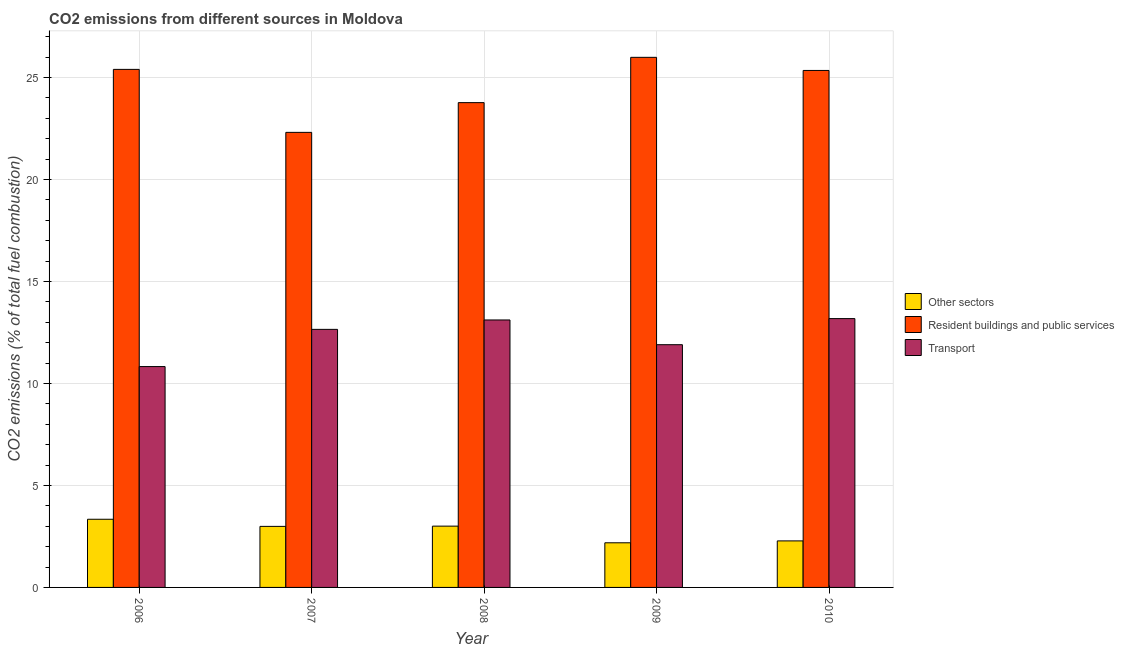How many different coloured bars are there?
Offer a terse response. 3. Are the number of bars per tick equal to the number of legend labels?
Offer a very short reply. Yes. How many bars are there on the 2nd tick from the left?
Keep it short and to the point. 3. What is the label of the 1st group of bars from the left?
Offer a terse response. 2006. What is the percentage of co2 emissions from transport in 2007?
Make the answer very short. 12.65. Across all years, what is the maximum percentage of co2 emissions from transport?
Offer a terse response. 13.18. Across all years, what is the minimum percentage of co2 emissions from resident buildings and public services?
Your answer should be very brief. 22.31. In which year was the percentage of co2 emissions from other sectors minimum?
Provide a succinct answer. 2009. What is the total percentage of co2 emissions from other sectors in the graph?
Your answer should be very brief. 13.81. What is the difference between the percentage of co2 emissions from resident buildings and public services in 2008 and that in 2010?
Keep it short and to the point. -1.58. What is the difference between the percentage of co2 emissions from transport in 2007 and the percentage of co2 emissions from resident buildings and public services in 2006?
Keep it short and to the point. 1.82. What is the average percentage of co2 emissions from other sectors per year?
Offer a terse response. 2.76. In the year 2009, what is the difference between the percentage of co2 emissions from transport and percentage of co2 emissions from resident buildings and public services?
Your answer should be very brief. 0. In how many years, is the percentage of co2 emissions from resident buildings and public services greater than 17 %?
Your answer should be very brief. 5. What is the ratio of the percentage of co2 emissions from transport in 2006 to that in 2008?
Your response must be concise. 0.83. Is the percentage of co2 emissions from transport in 2006 less than that in 2010?
Provide a succinct answer. Yes. What is the difference between the highest and the second highest percentage of co2 emissions from resident buildings and public services?
Provide a short and direct response. 0.59. What is the difference between the highest and the lowest percentage of co2 emissions from other sectors?
Keep it short and to the point. 1.15. In how many years, is the percentage of co2 emissions from transport greater than the average percentage of co2 emissions from transport taken over all years?
Keep it short and to the point. 3. Is the sum of the percentage of co2 emissions from other sectors in 2007 and 2008 greater than the maximum percentage of co2 emissions from resident buildings and public services across all years?
Offer a very short reply. Yes. What does the 1st bar from the left in 2008 represents?
Provide a short and direct response. Other sectors. What does the 3rd bar from the right in 2010 represents?
Your answer should be very brief. Other sectors. Is it the case that in every year, the sum of the percentage of co2 emissions from other sectors and percentage of co2 emissions from resident buildings and public services is greater than the percentage of co2 emissions from transport?
Ensure brevity in your answer.  Yes. Are all the bars in the graph horizontal?
Ensure brevity in your answer.  No. Are the values on the major ticks of Y-axis written in scientific E-notation?
Keep it short and to the point. No. Where does the legend appear in the graph?
Your response must be concise. Center right. How many legend labels are there?
Your answer should be compact. 3. What is the title of the graph?
Offer a terse response. CO2 emissions from different sources in Moldova. What is the label or title of the X-axis?
Ensure brevity in your answer.  Year. What is the label or title of the Y-axis?
Offer a very short reply. CO2 emissions (% of total fuel combustion). What is the CO2 emissions (% of total fuel combustion) of Other sectors in 2006?
Make the answer very short. 3.34. What is the CO2 emissions (% of total fuel combustion) in Resident buildings and public services in 2006?
Offer a terse response. 25.4. What is the CO2 emissions (% of total fuel combustion) of Transport in 2006?
Your answer should be very brief. 10.83. What is the CO2 emissions (% of total fuel combustion) of Other sectors in 2007?
Make the answer very short. 2.99. What is the CO2 emissions (% of total fuel combustion) in Resident buildings and public services in 2007?
Ensure brevity in your answer.  22.31. What is the CO2 emissions (% of total fuel combustion) of Transport in 2007?
Your answer should be compact. 12.65. What is the CO2 emissions (% of total fuel combustion) of Other sectors in 2008?
Make the answer very short. 3.01. What is the CO2 emissions (% of total fuel combustion) of Resident buildings and public services in 2008?
Offer a very short reply. 23.77. What is the CO2 emissions (% of total fuel combustion) of Transport in 2008?
Offer a terse response. 13.11. What is the CO2 emissions (% of total fuel combustion) of Other sectors in 2009?
Offer a terse response. 2.19. What is the CO2 emissions (% of total fuel combustion) in Resident buildings and public services in 2009?
Offer a very short reply. 25.99. What is the CO2 emissions (% of total fuel combustion) of Transport in 2009?
Give a very brief answer. 11.9. What is the CO2 emissions (% of total fuel combustion) in Other sectors in 2010?
Offer a very short reply. 2.28. What is the CO2 emissions (% of total fuel combustion) in Resident buildings and public services in 2010?
Give a very brief answer. 25.35. What is the CO2 emissions (% of total fuel combustion) in Transport in 2010?
Offer a very short reply. 13.18. Across all years, what is the maximum CO2 emissions (% of total fuel combustion) of Other sectors?
Ensure brevity in your answer.  3.34. Across all years, what is the maximum CO2 emissions (% of total fuel combustion) of Resident buildings and public services?
Your answer should be compact. 25.99. Across all years, what is the maximum CO2 emissions (% of total fuel combustion) of Transport?
Provide a succinct answer. 13.18. Across all years, what is the minimum CO2 emissions (% of total fuel combustion) in Other sectors?
Provide a succinct answer. 2.19. Across all years, what is the minimum CO2 emissions (% of total fuel combustion) of Resident buildings and public services?
Provide a succinct answer. 22.31. Across all years, what is the minimum CO2 emissions (% of total fuel combustion) in Transport?
Keep it short and to the point. 10.83. What is the total CO2 emissions (% of total fuel combustion) in Other sectors in the graph?
Give a very brief answer. 13.81. What is the total CO2 emissions (% of total fuel combustion) in Resident buildings and public services in the graph?
Make the answer very short. 122.82. What is the total CO2 emissions (% of total fuel combustion) of Transport in the graph?
Provide a short and direct response. 61.68. What is the difference between the CO2 emissions (% of total fuel combustion) of Other sectors in 2006 and that in 2007?
Give a very brief answer. 0.35. What is the difference between the CO2 emissions (% of total fuel combustion) in Resident buildings and public services in 2006 and that in 2007?
Make the answer very short. 3.09. What is the difference between the CO2 emissions (% of total fuel combustion) in Transport in 2006 and that in 2007?
Provide a short and direct response. -1.82. What is the difference between the CO2 emissions (% of total fuel combustion) in Other sectors in 2006 and that in 2008?
Give a very brief answer. 0.34. What is the difference between the CO2 emissions (% of total fuel combustion) of Resident buildings and public services in 2006 and that in 2008?
Give a very brief answer. 1.63. What is the difference between the CO2 emissions (% of total fuel combustion) in Transport in 2006 and that in 2008?
Your answer should be compact. -2.29. What is the difference between the CO2 emissions (% of total fuel combustion) of Other sectors in 2006 and that in 2009?
Your response must be concise. 1.15. What is the difference between the CO2 emissions (% of total fuel combustion) in Resident buildings and public services in 2006 and that in 2009?
Your answer should be compact. -0.59. What is the difference between the CO2 emissions (% of total fuel combustion) in Transport in 2006 and that in 2009?
Give a very brief answer. -1.07. What is the difference between the CO2 emissions (% of total fuel combustion) of Other sectors in 2006 and that in 2010?
Provide a short and direct response. 1.06. What is the difference between the CO2 emissions (% of total fuel combustion) of Resident buildings and public services in 2006 and that in 2010?
Provide a short and direct response. 0.05. What is the difference between the CO2 emissions (% of total fuel combustion) in Transport in 2006 and that in 2010?
Provide a succinct answer. -2.35. What is the difference between the CO2 emissions (% of total fuel combustion) of Other sectors in 2007 and that in 2008?
Provide a short and direct response. -0.01. What is the difference between the CO2 emissions (% of total fuel combustion) of Resident buildings and public services in 2007 and that in 2008?
Make the answer very short. -1.46. What is the difference between the CO2 emissions (% of total fuel combustion) in Transport in 2007 and that in 2008?
Give a very brief answer. -0.46. What is the difference between the CO2 emissions (% of total fuel combustion) of Other sectors in 2007 and that in 2009?
Make the answer very short. 0.8. What is the difference between the CO2 emissions (% of total fuel combustion) of Resident buildings and public services in 2007 and that in 2009?
Your answer should be very brief. -3.68. What is the difference between the CO2 emissions (% of total fuel combustion) in Transport in 2007 and that in 2009?
Provide a short and direct response. 0.75. What is the difference between the CO2 emissions (% of total fuel combustion) in Other sectors in 2007 and that in 2010?
Your response must be concise. 0.71. What is the difference between the CO2 emissions (% of total fuel combustion) of Resident buildings and public services in 2007 and that in 2010?
Your answer should be compact. -3.04. What is the difference between the CO2 emissions (% of total fuel combustion) of Transport in 2007 and that in 2010?
Your answer should be compact. -0.53. What is the difference between the CO2 emissions (% of total fuel combustion) of Other sectors in 2008 and that in 2009?
Keep it short and to the point. 0.82. What is the difference between the CO2 emissions (% of total fuel combustion) of Resident buildings and public services in 2008 and that in 2009?
Your answer should be compact. -2.22. What is the difference between the CO2 emissions (% of total fuel combustion) in Transport in 2008 and that in 2009?
Offer a terse response. 1.21. What is the difference between the CO2 emissions (% of total fuel combustion) in Other sectors in 2008 and that in 2010?
Provide a short and direct response. 0.72. What is the difference between the CO2 emissions (% of total fuel combustion) of Resident buildings and public services in 2008 and that in 2010?
Provide a succinct answer. -1.58. What is the difference between the CO2 emissions (% of total fuel combustion) in Transport in 2008 and that in 2010?
Your answer should be very brief. -0.07. What is the difference between the CO2 emissions (% of total fuel combustion) in Other sectors in 2009 and that in 2010?
Keep it short and to the point. -0.09. What is the difference between the CO2 emissions (% of total fuel combustion) of Resident buildings and public services in 2009 and that in 2010?
Your answer should be compact. 0.64. What is the difference between the CO2 emissions (% of total fuel combustion) of Transport in 2009 and that in 2010?
Ensure brevity in your answer.  -1.28. What is the difference between the CO2 emissions (% of total fuel combustion) in Other sectors in 2006 and the CO2 emissions (% of total fuel combustion) in Resident buildings and public services in 2007?
Offer a very short reply. -18.97. What is the difference between the CO2 emissions (% of total fuel combustion) of Other sectors in 2006 and the CO2 emissions (% of total fuel combustion) of Transport in 2007?
Provide a short and direct response. -9.31. What is the difference between the CO2 emissions (% of total fuel combustion) of Resident buildings and public services in 2006 and the CO2 emissions (% of total fuel combustion) of Transport in 2007?
Your answer should be compact. 12.75. What is the difference between the CO2 emissions (% of total fuel combustion) of Other sectors in 2006 and the CO2 emissions (% of total fuel combustion) of Resident buildings and public services in 2008?
Your answer should be compact. -20.43. What is the difference between the CO2 emissions (% of total fuel combustion) in Other sectors in 2006 and the CO2 emissions (% of total fuel combustion) in Transport in 2008?
Make the answer very short. -9.77. What is the difference between the CO2 emissions (% of total fuel combustion) of Resident buildings and public services in 2006 and the CO2 emissions (% of total fuel combustion) of Transport in 2008?
Keep it short and to the point. 12.29. What is the difference between the CO2 emissions (% of total fuel combustion) of Other sectors in 2006 and the CO2 emissions (% of total fuel combustion) of Resident buildings and public services in 2009?
Your answer should be compact. -22.65. What is the difference between the CO2 emissions (% of total fuel combustion) in Other sectors in 2006 and the CO2 emissions (% of total fuel combustion) in Transport in 2009?
Your answer should be compact. -8.56. What is the difference between the CO2 emissions (% of total fuel combustion) of Resident buildings and public services in 2006 and the CO2 emissions (% of total fuel combustion) of Transport in 2009?
Give a very brief answer. 13.5. What is the difference between the CO2 emissions (% of total fuel combustion) of Other sectors in 2006 and the CO2 emissions (% of total fuel combustion) of Resident buildings and public services in 2010?
Keep it short and to the point. -22.01. What is the difference between the CO2 emissions (% of total fuel combustion) of Other sectors in 2006 and the CO2 emissions (% of total fuel combustion) of Transport in 2010?
Provide a succinct answer. -9.84. What is the difference between the CO2 emissions (% of total fuel combustion) in Resident buildings and public services in 2006 and the CO2 emissions (% of total fuel combustion) in Transport in 2010?
Keep it short and to the point. 12.22. What is the difference between the CO2 emissions (% of total fuel combustion) in Other sectors in 2007 and the CO2 emissions (% of total fuel combustion) in Resident buildings and public services in 2008?
Provide a short and direct response. -20.78. What is the difference between the CO2 emissions (% of total fuel combustion) in Other sectors in 2007 and the CO2 emissions (% of total fuel combustion) in Transport in 2008?
Offer a terse response. -10.12. What is the difference between the CO2 emissions (% of total fuel combustion) in Resident buildings and public services in 2007 and the CO2 emissions (% of total fuel combustion) in Transport in 2008?
Give a very brief answer. 9.2. What is the difference between the CO2 emissions (% of total fuel combustion) of Other sectors in 2007 and the CO2 emissions (% of total fuel combustion) of Resident buildings and public services in 2009?
Provide a short and direct response. -23. What is the difference between the CO2 emissions (% of total fuel combustion) in Other sectors in 2007 and the CO2 emissions (% of total fuel combustion) in Transport in 2009?
Offer a terse response. -8.91. What is the difference between the CO2 emissions (% of total fuel combustion) in Resident buildings and public services in 2007 and the CO2 emissions (% of total fuel combustion) in Transport in 2009?
Provide a succinct answer. 10.41. What is the difference between the CO2 emissions (% of total fuel combustion) of Other sectors in 2007 and the CO2 emissions (% of total fuel combustion) of Resident buildings and public services in 2010?
Offer a terse response. -22.36. What is the difference between the CO2 emissions (% of total fuel combustion) in Other sectors in 2007 and the CO2 emissions (% of total fuel combustion) in Transport in 2010?
Make the answer very short. -10.19. What is the difference between the CO2 emissions (% of total fuel combustion) of Resident buildings and public services in 2007 and the CO2 emissions (% of total fuel combustion) of Transport in 2010?
Your answer should be compact. 9.13. What is the difference between the CO2 emissions (% of total fuel combustion) of Other sectors in 2008 and the CO2 emissions (% of total fuel combustion) of Resident buildings and public services in 2009?
Your response must be concise. -22.99. What is the difference between the CO2 emissions (% of total fuel combustion) in Other sectors in 2008 and the CO2 emissions (% of total fuel combustion) in Transport in 2009?
Offer a very short reply. -8.9. What is the difference between the CO2 emissions (% of total fuel combustion) of Resident buildings and public services in 2008 and the CO2 emissions (% of total fuel combustion) of Transport in 2009?
Offer a very short reply. 11.87. What is the difference between the CO2 emissions (% of total fuel combustion) of Other sectors in 2008 and the CO2 emissions (% of total fuel combustion) of Resident buildings and public services in 2010?
Give a very brief answer. -22.34. What is the difference between the CO2 emissions (% of total fuel combustion) of Other sectors in 2008 and the CO2 emissions (% of total fuel combustion) of Transport in 2010?
Your response must be concise. -10.18. What is the difference between the CO2 emissions (% of total fuel combustion) of Resident buildings and public services in 2008 and the CO2 emissions (% of total fuel combustion) of Transport in 2010?
Ensure brevity in your answer.  10.59. What is the difference between the CO2 emissions (% of total fuel combustion) in Other sectors in 2009 and the CO2 emissions (% of total fuel combustion) in Resident buildings and public services in 2010?
Offer a very short reply. -23.16. What is the difference between the CO2 emissions (% of total fuel combustion) in Other sectors in 2009 and the CO2 emissions (% of total fuel combustion) in Transport in 2010?
Keep it short and to the point. -10.99. What is the difference between the CO2 emissions (% of total fuel combustion) in Resident buildings and public services in 2009 and the CO2 emissions (% of total fuel combustion) in Transport in 2010?
Make the answer very short. 12.81. What is the average CO2 emissions (% of total fuel combustion) of Other sectors per year?
Provide a short and direct response. 2.76. What is the average CO2 emissions (% of total fuel combustion) of Resident buildings and public services per year?
Your response must be concise. 24.57. What is the average CO2 emissions (% of total fuel combustion) of Transport per year?
Your response must be concise. 12.34. In the year 2006, what is the difference between the CO2 emissions (% of total fuel combustion) in Other sectors and CO2 emissions (% of total fuel combustion) in Resident buildings and public services?
Make the answer very short. -22.06. In the year 2006, what is the difference between the CO2 emissions (% of total fuel combustion) in Other sectors and CO2 emissions (% of total fuel combustion) in Transport?
Keep it short and to the point. -7.49. In the year 2006, what is the difference between the CO2 emissions (% of total fuel combustion) of Resident buildings and public services and CO2 emissions (% of total fuel combustion) of Transport?
Offer a terse response. 14.57. In the year 2007, what is the difference between the CO2 emissions (% of total fuel combustion) in Other sectors and CO2 emissions (% of total fuel combustion) in Resident buildings and public services?
Your answer should be very brief. -19.32. In the year 2007, what is the difference between the CO2 emissions (% of total fuel combustion) of Other sectors and CO2 emissions (% of total fuel combustion) of Transport?
Ensure brevity in your answer.  -9.66. In the year 2007, what is the difference between the CO2 emissions (% of total fuel combustion) of Resident buildings and public services and CO2 emissions (% of total fuel combustion) of Transport?
Ensure brevity in your answer.  9.66. In the year 2008, what is the difference between the CO2 emissions (% of total fuel combustion) in Other sectors and CO2 emissions (% of total fuel combustion) in Resident buildings and public services?
Provide a short and direct response. -20.77. In the year 2008, what is the difference between the CO2 emissions (% of total fuel combustion) of Other sectors and CO2 emissions (% of total fuel combustion) of Transport?
Provide a succinct answer. -10.11. In the year 2008, what is the difference between the CO2 emissions (% of total fuel combustion) in Resident buildings and public services and CO2 emissions (% of total fuel combustion) in Transport?
Offer a very short reply. 10.66. In the year 2009, what is the difference between the CO2 emissions (% of total fuel combustion) in Other sectors and CO2 emissions (% of total fuel combustion) in Resident buildings and public services?
Give a very brief answer. -23.8. In the year 2009, what is the difference between the CO2 emissions (% of total fuel combustion) in Other sectors and CO2 emissions (% of total fuel combustion) in Transport?
Provide a succinct answer. -9.71. In the year 2009, what is the difference between the CO2 emissions (% of total fuel combustion) in Resident buildings and public services and CO2 emissions (% of total fuel combustion) in Transport?
Your answer should be compact. 14.09. In the year 2010, what is the difference between the CO2 emissions (% of total fuel combustion) in Other sectors and CO2 emissions (% of total fuel combustion) in Resident buildings and public services?
Offer a very short reply. -23.07. In the year 2010, what is the difference between the CO2 emissions (% of total fuel combustion) of Other sectors and CO2 emissions (% of total fuel combustion) of Transport?
Offer a very short reply. -10.9. In the year 2010, what is the difference between the CO2 emissions (% of total fuel combustion) of Resident buildings and public services and CO2 emissions (% of total fuel combustion) of Transport?
Your response must be concise. 12.17. What is the ratio of the CO2 emissions (% of total fuel combustion) of Other sectors in 2006 to that in 2007?
Your answer should be compact. 1.12. What is the ratio of the CO2 emissions (% of total fuel combustion) of Resident buildings and public services in 2006 to that in 2007?
Ensure brevity in your answer.  1.14. What is the ratio of the CO2 emissions (% of total fuel combustion) of Transport in 2006 to that in 2007?
Offer a terse response. 0.86. What is the ratio of the CO2 emissions (% of total fuel combustion) in Other sectors in 2006 to that in 2008?
Offer a terse response. 1.11. What is the ratio of the CO2 emissions (% of total fuel combustion) of Resident buildings and public services in 2006 to that in 2008?
Your answer should be compact. 1.07. What is the ratio of the CO2 emissions (% of total fuel combustion) of Transport in 2006 to that in 2008?
Give a very brief answer. 0.83. What is the ratio of the CO2 emissions (% of total fuel combustion) in Other sectors in 2006 to that in 2009?
Make the answer very short. 1.53. What is the ratio of the CO2 emissions (% of total fuel combustion) of Resident buildings and public services in 2006 to that in 2009?
Provide a short and direct response. 0.98. What is the ratio of the CO2 emissions (% of total fuel combustion) in Transport in 2006 to that in 2009?
Provide a succinct answer. 0.91. What is the ratio of the CO2 emissions (% of total fuel combustion) of Other sectors in 2006 to that in 2010?
Offer a very short reply. 1.47. What is the ratio of the CO2 emissions (% of total fuel combustion) in Transport in 2006 to that in 2010?
Give a very brief answer. 0.82. What is the ratio of the CO2 emissions (% of total fuel combustion) of Other sectors in 2007 to that in 2008?
Offer a terse response. 1. What is the ratio of the CO2 emissions (% of total fuel combustion) of Resident buildings and public services in 2007 to that in 2008?
Your answer should be compact. 0.94. What is the ratio of the CO2 emissions (% of total fuel combustion) in Transport in 2007 to that in 2008?
Offer a very short reply. 0.96. What is the ratio of the CO2 emissions (% of total fuel combustion) of Other sectors in 2007 to that in 2009?
Offer a very short reply. 1.37. What is the ratio of the CO2 emissions (% of total fuel combustion) of Resident buildings and public services in 2007 to that in 2009?
Give a very brief answer. 0.86. What is the ratio of the CO2 emissions (% of total fuel combustion) of Transport in 2007 to that in 2009?
Ensure brevity in your answer.  1.06. What is the ratio of the CO2 emissions (% of total fuel combustion) in Other sectors in 2007 to that in 2010?
Give a very brief answer. 1.31. What is the ratio of the CO2 emissions (% of total fuel combustion) in Resident buildings and public services in 2007 to that in 2010?
Offer a terse response. 0.88. What is the ratio of the CO2 emissions (% of total fuel combustion) in Transport in 2007 to that in 2010?
Your answer should be compact. 0.96. What is the ratio of the CO2 emissions (% of total fuel combustion) of Other sectors in 2008 to that in 2009?
Provide a succinct answer. 1.37. What is the ratio of the CO2 emissions (% of total fuel combustion) in Resident buildings and public services in 2008 to that in 2009?
Offer a very short reply. 0.91. What is the ratio of the CO2 emissions (% of total fuel combustion) of Transport in 2008 to that in 2009?
Give a very brief answer. 1.1. What is the ratio of the CO2 emissions (% of total fuel combustion) in Other sectors in 2008 to that in 2010?
Offer a very short reply. 1.32. What is the ratio of the CO2 emissions (% of total fuel combustion) of Resident buildings and public services in 2008 to that in 2010?
Make the answer very short. 0.94. What is the ratio of the CO2 emissions (% of total fuel combustion) in Other sectors in 2009 to that in 2010?
Your response must be concise. 0.96. What is the ratio of the CO2 emissions (% of total fuel combustion) in Resident buildings and public services in 2009 to that in 2010?
Your response must be concise. 1.03. What is the ratio of the CO2 emissions (% of total fuel combustion) in Transport in 2009 to that in 2010?
Offer a very short reply. 0.9. What is the difference between the highest and the second highest CO2 emissions (% of total fuel combustion) of Other sectors?
Provide a short and direct response. 0.34. What is the difference between the highest and the second highest CO2 emissions (% of total fuel combustion) of Resident buildings and public services?
Your response must be concise. 0.59. What is the difference between the highest and the second highest CO2 emissions (% of total fuel combustion) in Transport?
Your response must be concise. 0.07. What is the difference between the highest and the lowest CO2 emissions (% of total fuel combustion) in Other sectors?
Keep it short and to the point. 1.15. What is the difference between the highest and the lowest CO2 emissions (% of total fuel combustion) of Resident buildings and public services?
Your answer should be compact. 3.68. What is the difference between the highest and the lowest CO2 emissions (% of total fuel combustion) of Transport?
Your answer should be compact. 2.35. 